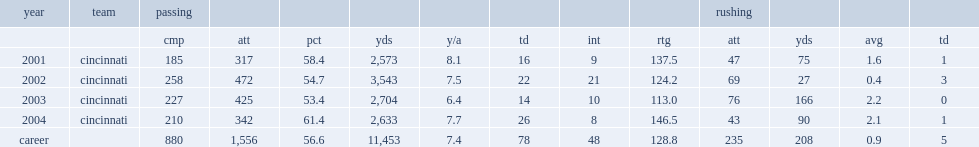How many yards did gino guidugli rush for in his career? 208.0. How many carries did gino guidugli rush for in his career? 235.0. 